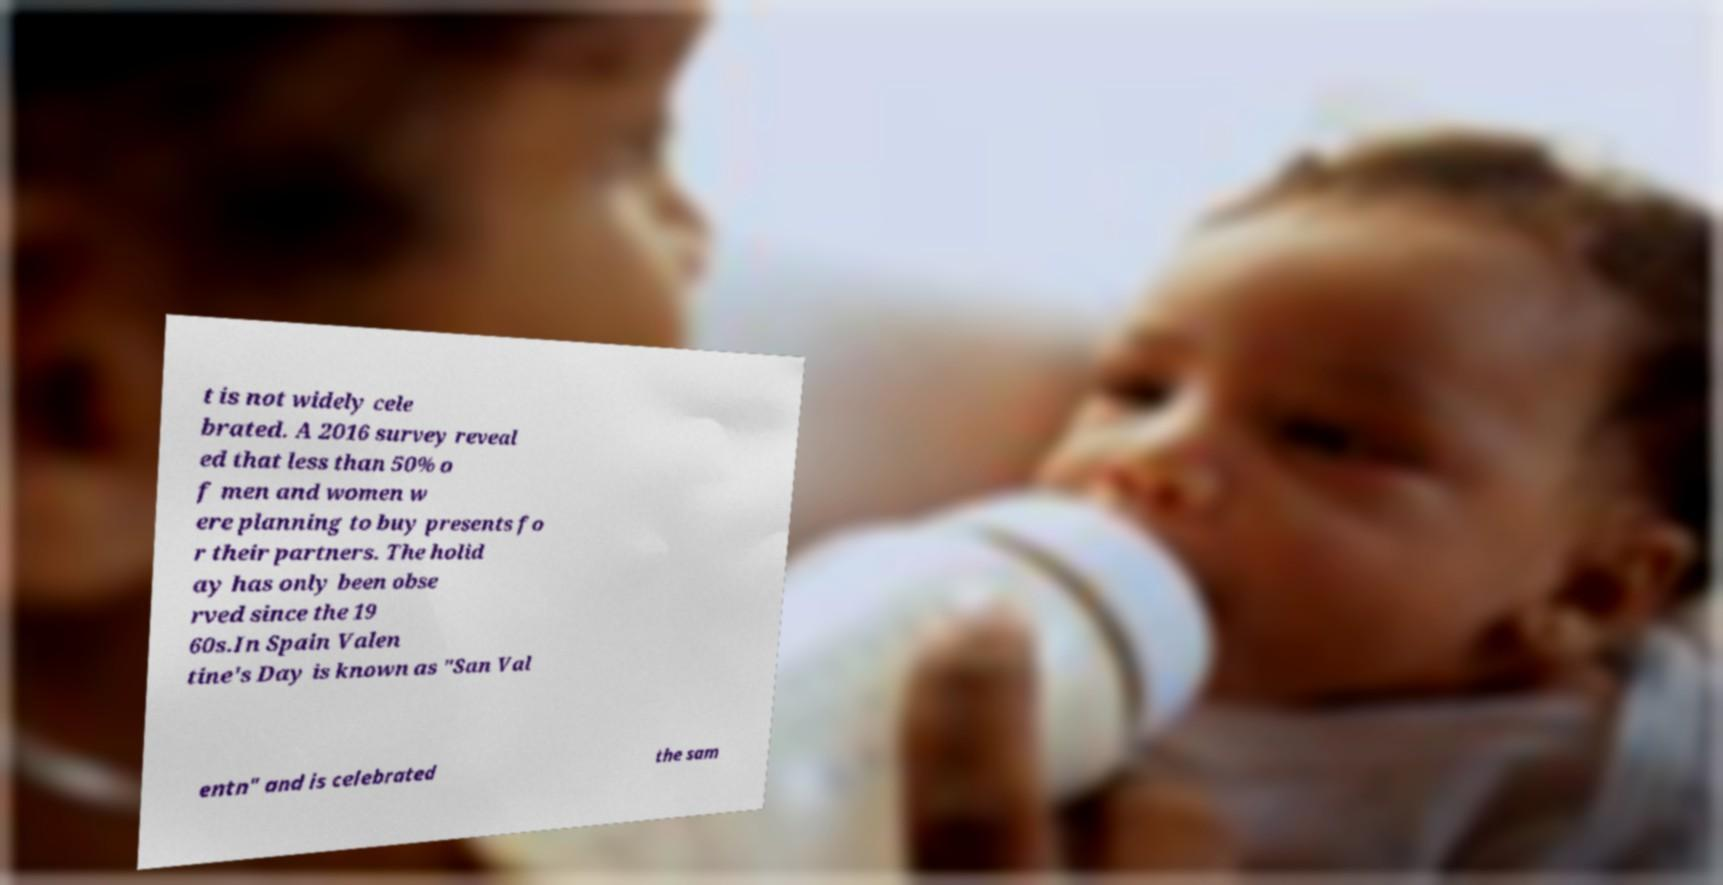For documentation purposes, I need the text within this image transcribed. Could you provide that? t is not widely cele brated. A 2016 survey reveal ed that less than 50% o f men and women w ere planning to buy presents fo r their partners. The holid ay has only been obse rved since the 19 60s.In Spain Valen tine's Day is known as "San Val entn" and is celebrated the sam 